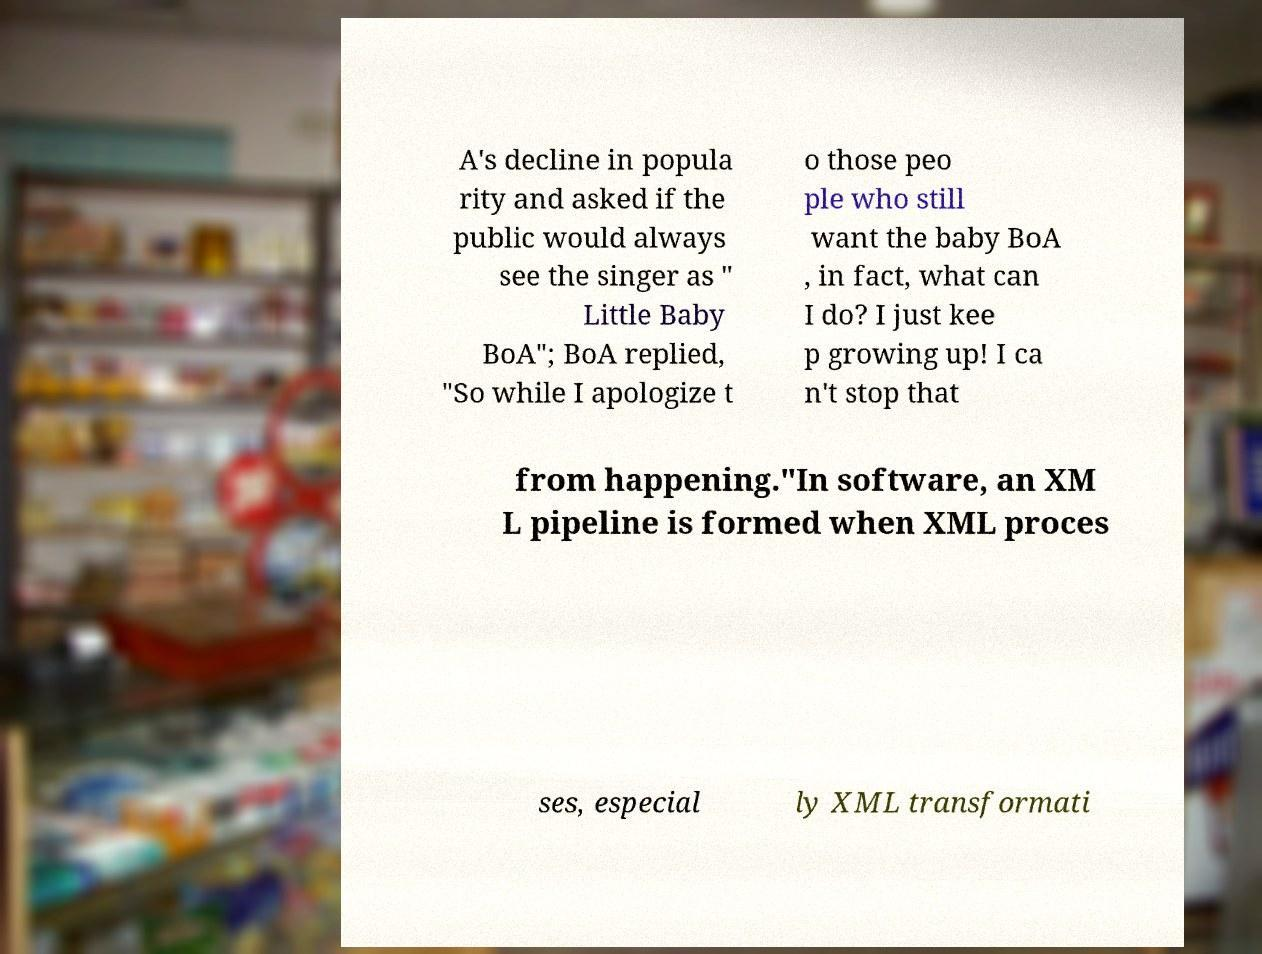Could you extract and type out the text from this image? A's decline in popula rity and asked if the public would always see the singer as " Little Baby BoA"; BoA replied, "So while I apologize t o those peo ple who still want the baby BoA , in fact, what can I do? I just kee p growing up! I ca n't stop that from happening."In software, an XM L pipeline is formed when XML proces ses, especial ly XML transformati 